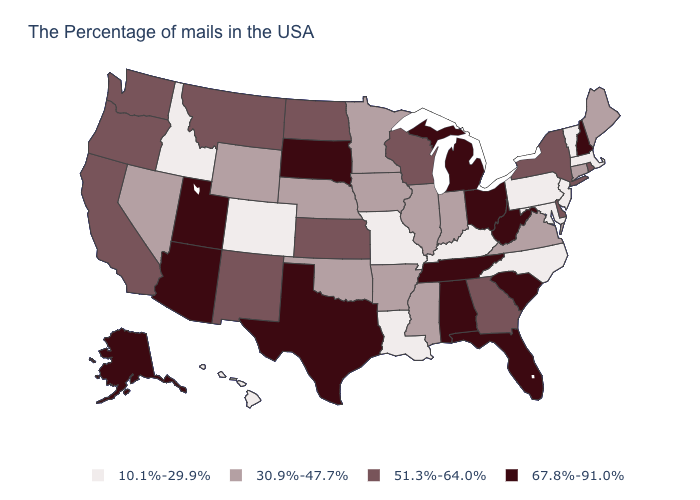What is the value of Tennessee?
Answer briefly. 67.8%-91.0%. What is the value of Nevada?
Be succinct. 30.9%-47.7%. Which states hav the highest value in the MidWest?
Short answer required. Ohio, Michigan, South Dakota. What is the value of Indiana?
Give a very brief answer. 30.9%-47.7%. What is the value of Missouri?
Concise answer only. 10.1%-29.9%. What is the highest value in the West ?
Give a very brief answer. 67.8%-91.0%. Name the states that have a value in the range 30.9%-47.7%?
Keep it brief. Maine, Connecticut, Virginia, Indiana, Illinois, Mississippi, Arkansas, Minnesota, Iowa, Nebraska, Oklahoma, Wyoming, Nevada. Name the states that have a value in the range 67.8%-91.0%?
Write a very short answer. New Hampshire, South Carolina, West Virginia, Ohio, Florida, Michigan, Alabama, Tennessee, Texas, South Dakota, Utah, Arizona, Alaska. What is the value of Louisiana?
Be succinct. 10.1%-29.9%. What is the lowest value in the USA?
Write a very short answer. 10.1%-29.9%. What is the value of Montana?
Short answer required. 51.3%-64.0%. Name the states that have a value in the range 51.3%-64.0%?
Write a very short answer. Rhode Island, New York, Delaware, Georgia, Wisconsin, Kansas, North Dakota, New Mexico, Montana, California, Washington, Oregon. What is the highest value in the USA?
Quick response, please. 67.8%-91.0%. Among the states that border Georgia , does North Carolina have the highest value?
Keep it brief. No. Name the states that have a value in the range 30.9%-47.7%?
Short answer required. Maine, Connecticut, Virginia, Indiana, Illinois, Mississippi, Arkansas, Minnesota, Iowa, Nebraska, Oklahoma, Wyoming, Nevada. 